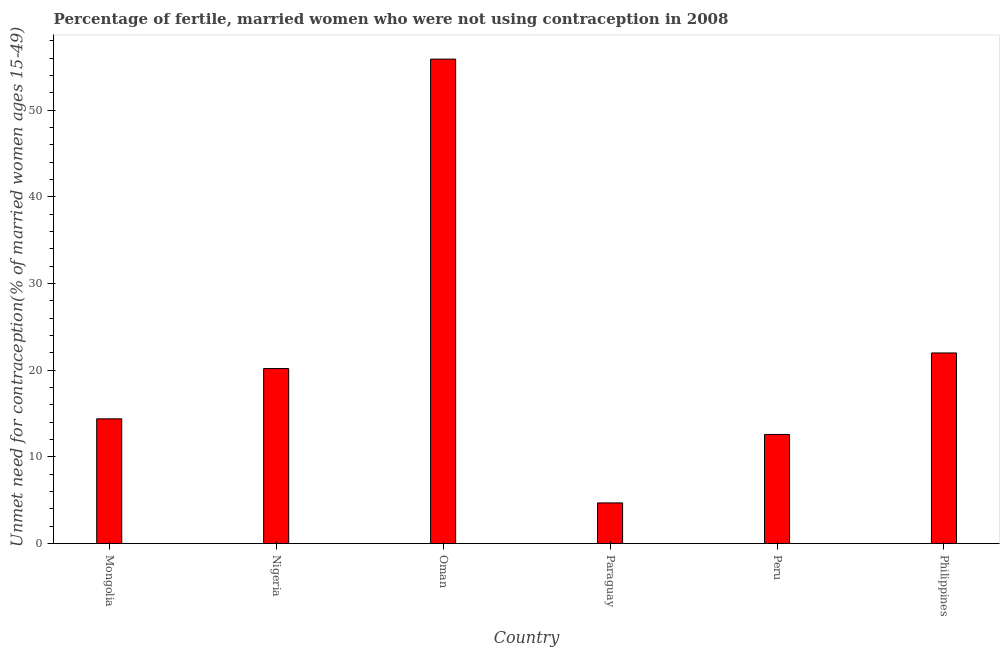Does the graph contain any zero values?
Provide a succinct answer. No. What is the title of the graph?
Offer a terse response. Percentage of fertile, married women who were not using contraception in 2008. What is the label or title of the X-axis?
Keep it short and to the point. Country. What is the label or title of the Y-axis?
Keep it short and to the point.  Unmet need for contraception(% of married women ages 15-49). Across all countries, what is the maximum number of married women who are not using contraception?
Provide a succinct answer. 55.9. In which country was the number of married women who are not using contraception maximum?
Ensure brevity in your answer.  Oman. In which country was the number of married women who are not using contraception minimum?
Keep it short and to the point. Paraguay. What is the sum of the number of married women who are not using contraception?
Your answer should be compact. 129.8. What is the difference between the number of married women who are not using contraception in Mongolia and Oman?
Your answer should be compact. -41.5. What is the average number of married women who are not using contraception per country?
Make the answer very short. 21.63. What is the ratio of the number of married women who are not using contraception in Paraguay to that in Philippines?
Your response must be concise. 0.21. Is the number of married women who are not using contraception in Mongolia less than that in Philippines?
Provide a short and direct response. Yes. What is the difference between the highest and the second highest number of married women who are not using contraception?
Provide a short and direct response. 33.9. What is the difference between the highest and the lowest number of married women who are not using contraception?
Make the answer very short. 51.2. In how many countries, is the number of married women who are not using contraception greater than the average number of married women who are not using contraception taken over all countries?
Your answer should be very brief. 2. How many countries are there in the graph?
Your answer should be very brief. 6. What is the difference between two consecutive major ticks on the Y-axis?
Offer a very short reply. 10. Are the values on the major ticks of Y-axis written in scientific E-notation?
Your response must be concise. No. What is the  Unmet need for contraception(% of married women ages 15-49) in Nigeria?
Your answer should be compact. 20.2. What is the  Unmet need for contraception(% of married women ages 15-49) of Oman?
Provide a succinct answer. 55.9. What is the  Unmet need for contraception(% of married women ages 15-49) of Paraguay?
Keep it short and to the point. 4.7. What is the difference between the  Unmet need for contraception(% of married women ages 15-49) in Mongolia and Oman?
Offer a very short reply. -41.5. What is the difference between the  Unmet need for contraception(% of married women ages 15-49) in Mongolia and Paraguay?
Offer a very short reply. 9.7. What is the difference between the  Unmet need for contraception(% of married women ages 15-49) in Mongolia and Philippines?
Offer a terse response. -7.6. What is the difference between the  Unmet need for contraception(% of married women ages 15-49) in Nigeria and Oman?
Offer a terse response. -35.7. What is the difference between the  Unmet need for contraception(% of married women ages 15-49) in Nigeria and Peru?
Offer a very short reply. 7.6. What is the difference between the  Unmet need for contraception(% of married women ages 15-49) in Nigeria and Philippines?
Your response must be concise. -1.8. What is the difference between the  Unmet need for contraception(% of married women ages 15-49) in Oman and Paraguay?
Your answer should be very brief. 51.2. What is the difference between the  Unmet need for contraception(% of married women ages 15-49) in Oman and Peru?
Provide a short and direct response. 43.3. What is the difference between the  Unmet need for contraception(% of married women ages 15-49) in Oman and Philippines?
Provide a short and direct response. 33.9. What is the difference between the  Unmet need for contraception(% of married women ages 15-49) in Paraguay and Philippines?
Make the answer very short. -17.3. What is the difference between the  Unmet need for contraception(% of married women ages 15-49) in Peru and Philippines?
Provide a succinct answer. -9.4. What is the ratio of the  Unmet need for contraception(% of married women ages 15-49) in Mongolia to that in Nigeria?
Your answer should be very brief. 0.71. What is the ratio of the  Unmet need for contraception(% of married women ages 15-49) in Mongolia to that in Oman?
Your answer should be compact. 0.26. What is the ratio of the  Unmet need for contraception(% of married women ages 15-49) in Mongolia to that in Paraguay?
Provide a short and direct response. 3.06. What is the ratio of the  Unmet need for contraception(% of married women ages 15-49) in Mongolia to that in Peru?
Provide a succinct answer. 1.14. What is the ratio of the  Unmet need for contraception(% of married women ages 15-49) in Mongolia to that in Philippines?
Your answer should be compact. 0.66. What is the ratio of the  Unmet need for contraception(% of married women ages 15-49) in Nigeria to that in Oman?
Provide a short and direct response. 0.36. What is the ratio of the  Unmet need for contraception(% of married women ages 15-49) in Nigeria to that in Paraguay?
Make the answer very short. 4.3. What is the ratio of the  Unmet need for contraception(% of married women ages 15-49) in Nigeria to that in Peru?
Offer a very short reply. 1.6. What is the ratio of the  Unmet need for contraception(% of married women ages 15-49) in Nigeria to that in Philippines?
Your answer should be compact. 0.92. What is the ratio of the  Unmet need for contraception(% of married women ages 15-49) in Oman to that in Paraguay?
Your response must be concise. 11.89. What is the ratio of the  Unmet need for contraception(% of married women ages 15-49) in Oman to that in Peru?
Keep it short and to the point. 4.44. What is the ratio of the  Unmet need for contraception(% of married women ages 15-49) in Oman to that in Philippines?
Provide a succinct answer. 2.54. What is the ratio of the  Unmet need for contraception(% of married women ages 15-49) in Paraguay to that in Peru?
Your response must be concise. 0.37. What is the ratio of the  Unmet need for contraception(% of married women ages 15-49) in Paraguay to that in Philippines?
Give a very brief answer. 0.21. What is the ratio of the  Unmet need for contraception(% of married women ages 15-49) in Peru to that in Philippines?
Your response must be concise. 0.57. 